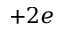Convert formula to latex. <formula><loc_0><loc_0><loc_500><loc_500>+ 2 e</formula> 